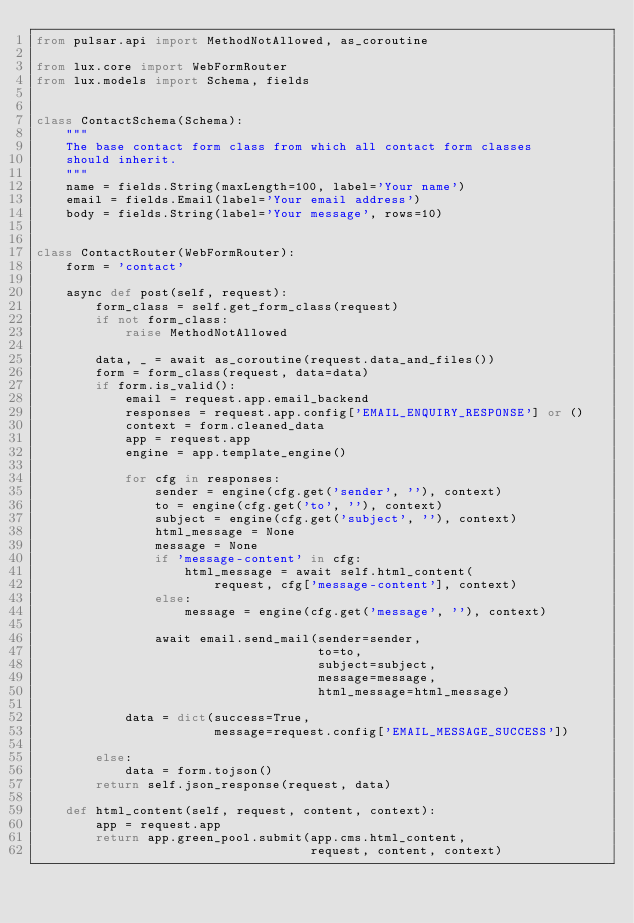Convert code to text. <code><loc_0><loc_0><loc_500><loc_500><_Python_>from pulsar.api import MethodNotAllowed, as_coroutine

from lux.core import WebFormRouter
from lux.models import Schema, fields


class ContactSchema(Schema):
    """
    The base contact form class from which all contact form classes
    should inherit.
    """
    name = fields.String(maxLength=100, label='Your name')
    email = fields.Email(label='Your email address')
    body = fields.String(label='Your message', rows=10)


class ContactRouter(WebFormRouter):
    form = 'contact'

    async def post(self, request):
        form_class = self.get_form_class(request)
        if not form_class:
            raise MethodNotAllowed

        data, _ = await as_coroutine(request.data_and_files())
        form = form_class(request, data=data)
        if form.is_valid():
            email = request.app.email_backend
            responses = request.app.config['EMAIL_ENQUIRY_RESPONSE'] or ()
            context = form.cleaned_data
            app = request.app
            engine = app.template_engine()

            for cfg in responses:
                sender = engine(cfg.get('sender', ''), context)
                to = engine(cfg.get('to', ''), context)
                subject = engine(cfg.get('subject', ''), context)
                html_message = None
                message = None
                if 'message-content' in cfg:
                    html_message = await self.html_content(
                        request, cfg['message-content'], context)
                else:
                    message = engine(cfg.get('message', ''), context)

                await email.send_mail(sender=sender,
                                      to=to,
                                      subject=subject,
                                      message=message,
                                      html_message=html_message)

            data = dict(success=True,
                        message=request.config['EMAIL_MESSAGE_SUCCESS'])

        else:
            data = form.tojson()
        return self.json_response(request, data)

    def html_content(self, request, content, context):
        app = request.app
        return app.green_pool.submit(app.cms.html_content,
                                     request, content, context)
</code> 